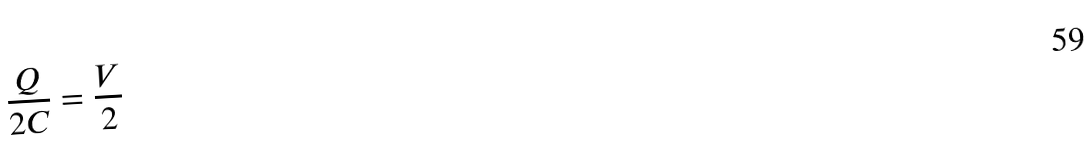<formula> <loc_0><loc_0><loc_500><loc_500>\frac { Q } { 2 C } = \frac { V } { 2 }</formula> 